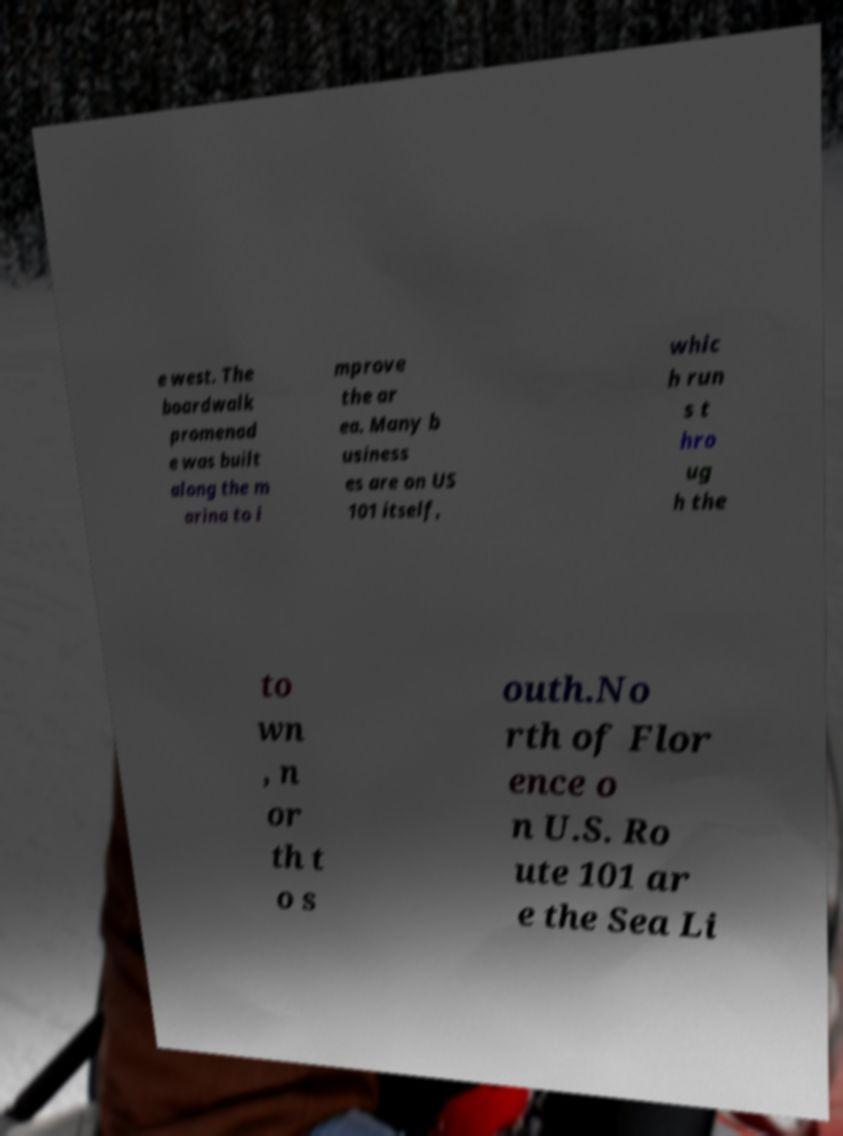I need the written content from this picture converted into text. Can you do that? e west. The boardwalk promenad e was built along the m arina to i mprove the ar ea. Many b usiness es are on US 101 itself, whic h run s t hro ug h the to wn , n or th t o s outh.No rth of Flor ence o n U.S. Ro ute 101 ar e the Sea Li 